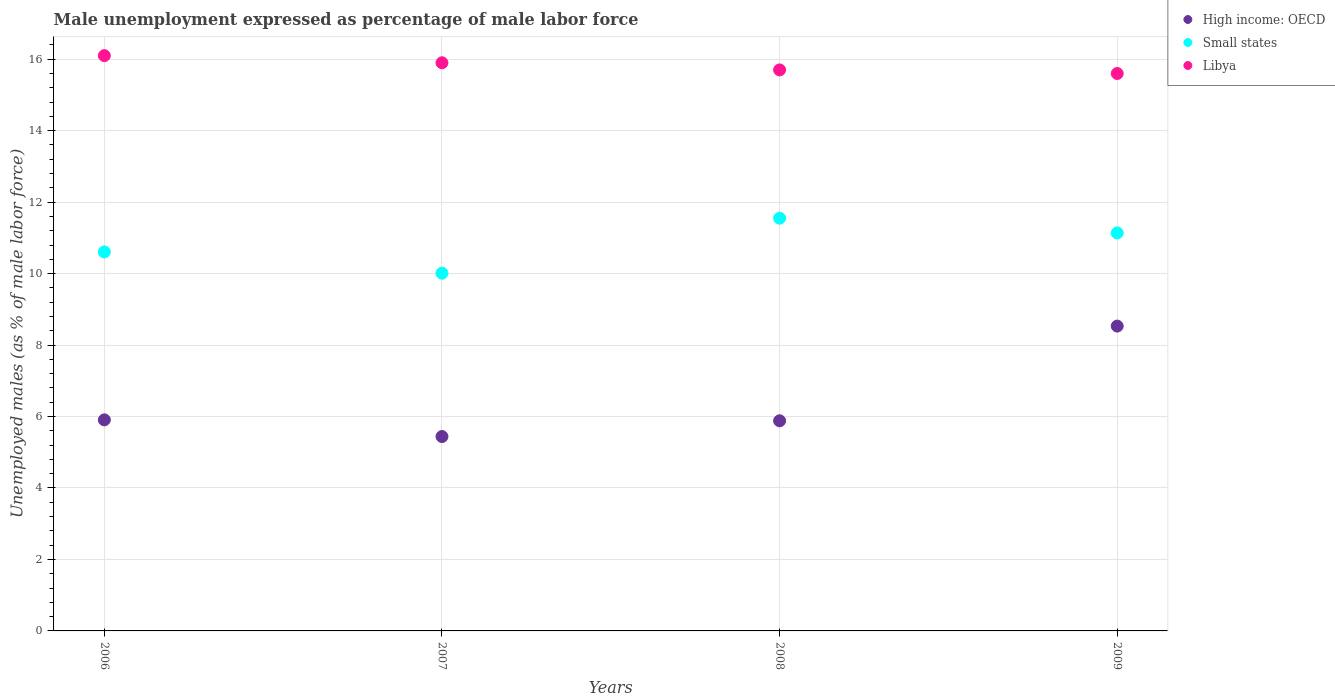How many different coloured dotlines are there?
Ensure brevity in your answer.  3. Is the number of dotlines equal to the number of legend labels?
Keep it short and to the point. Yes. What is the unemployment in males in in High income: OECD in 2007?
Offer a terse response. 5.44. Across all years, what is the maximum unemployment in males in in High income: OECD?
Offer a terse response. 8.53. Across all years, what is the minimum unemployment in males in in Small states?
Your response must be concise. 10.01. In which year was the unemployment in males in in Small states maximum?
Your answer should be compact. 2008. In which year was the unemployment in males in in High income: OECD minimum?
Keep it short and to the point. 2007. What is the total unemployment in males in in Small states in the graph?
Your answer should be very brief. 43.31. What is the difference between the unemployment in males in in Small states in 2007 and that in 2009?
Your response must be concise. -1.13. What is the difference between the unemployment in males in in Small states in 2007 and the unemployment in males in in Libya in 2008?
Offer a terse response. -5.69. What is the average unemployment in males in in High income: OECD per year?
Ensure brevity in your answer.  6.44. In the year 2007, what is the difference between the unemployment in males in in Small states and unemployment in males in in High income: OECD?
Ensure brevity in your answer.  4.57. What is the ratio of the unemployment in males in in Libya in 2006 to that in 2009?
Offer a terse response. 1.03. What is the difference between the highest and the second highest unemployment in males in in Small states?
Give a very brief answer. 0.41. What is the difference between the highest and the lowest unemployment in males in in Small states?
Offer a very short reply. 1.54. Is the sum of the unemployment in males in in Libya in 2007 and 2009 greater than the maximum unemployment in males in in High income: OECD across all years?
Provide a succinct answer. Yes. Is it the case that in every year, the sum of the unemployment in males in in Small states and unemployment in males in in Libya  is greater than the unemployment in males in in High income: OECD?
Keep it short and to the point. Yes. Are the values on the major ticks of Y-axis written in scientific E-notation?
Offer a terse response. No. Does the graph contain any zero values?
Give a very brief answer. No. Where does the legend appear in the graph?
Make the answer very short. Top right. How are the legend labels stacked?
Provide a short and direct response. Vertical. What is the title of the graph?
Your response must be concise. Male unemployment expressed as percentage of male labor force. Does "Marshall Islands" appear as one of the legend labels in the graph?
Give a very brief answer. No. What is the label or title of the Y-axis?
Make the answer very short. Unemployed males (as % of male labor force). What is the Unemployed males (as % of male labor force) of High income: OECD in 2006?
Offer a very short reply. 5.91. What is the Unemployed males (as % of male labor force) of Small states in 2006?
Your answer should be compact. 10.61. What is the Unemployed males (as % of male labor force) of Libya in 2006?
Your response must be concise. 16.1. What is the Unemployed males (as % of male labor force) in High income: OECD in 2007?
Your response must be concise. 5.44. What is the Unemployed males (as % of male labor force) of Small states in 2007?
Provide a succinct answer. 10.01. What is the Unemployed males (as % of male labor force) in Libya in 2007?
Make the answer very short. 15.9. What is the Unemployed males (as % of male labor force) in High income: OECD in 2008?
Provide a succinct answer. 5.88. What is the Unemployed males (as % of male labor force) in Small states in 2008?
Provide a short and direct response. 11.55. What is the Unemployed males (as % of male labor force) in Libya in 2008?
Provide a short and direct response. 15.7. What is the Unemployed males (as % of male labor force) of High income: OECD in 2009?
Ensure brevity in your answer.  8.53. What is the Unemployed males (as % of male labor force) in Small states in 2009?
Your answer should be compact. 11.14. What is the Unemployed males (as % of male labor force) in Libya in 2009?
Keep it short and to the point. 15.6. Across all years, what is the maximum Unemployed males (as % of male labor force) in High income: OECD?
Offer a very short reply. 8.53. Across all years, what is the maximum Unemployed males (as % of male labor force) of Small states?
Keep it short and to the point. 11.55. Across all years, what is the maximum Unemployed males (as % of male labor force) of Libya?
Your response must be concise. 16.1. Across all years, what is the minimum Unemployed males (as % of male labor force) in High income: OECD?
Your response must be concise. 5.44. Across all years, what is the minimum Unemployed males (as % of male labor force) in Small states?
Your response must be concise. 10.01. Across all years, what is the minimum Unemployed males (as % of male labor force) of Libya?
Make the answer very short. 15.6. What is the total Unemployed males (as % of male labor force) in High income: OECD in the graph?
Your answer should be very brief. 25.76. What is the total Unemployed males (as % of male labor force) of Small states in the graph?
Your response must be concise. 43.31. What is the total Unemployed males (as % of male labor force) in Libya in the graph?
Your response must be concise. 63.3. What is the difference between the Unemployed males (as % of male labor force) of High income: OECD in 2006 and that in 2007?
Give a very brief answer. 0.47. What is the difference between the Unemployed males (as % of male labor force) of Small states in 2006 and that in 2007?
Offer a terse response. 0.6. What is the difference between the Unemployed males (as % of male labor force) of High income: OECD in 2006 and that in 2008?
Make the answer very short. 0.03. What is the difference between the Unemployed males (as % of male labor force) in Small states in 2006 and that in 2008?
Provide a succinct answer. -0.94. What is the difference between the Unemployed males (as % of male labor force) of High income: OECD in 2006 and that in 2009?
Ensure brevity in your answer.  -2.62. What is the difference between the Unemployed males (as % of male labor force) of Small states in 2006 and that in 2009?
Provide a short and direct response. -0.53. What is the difference between the Unemployed males (as % of male labor force) of Libya in 2006 and that in 2009?
Your answer should be very brief. 0.5. What is the difference between the Unemployed males (as % of male labor force) of High income: OECD in 2007 and that in 2008?
Keep it short and to the point. -0.44. What is the difference between the Unemployed males (as % of male labor force) in Small states in 2007 and that in 2008?
Ensure brevity in your answer.  -1.54. What is the difference between the Unemployed males (as % of male labor force) in Libya in 2007 and that in 2008?
Offer a very short reply. 0.2. What is the difference between the Unemployed males (as % of male labor force) of High income: OECD in 2007 and that in 2009?
Provide a short and direct response. -3.09. What is the difference between the Unemployed males (as % of male labor force) in Small states in 2007 and that in 2009?
Provide a short and direct response. -1.13. What is the difference between the Unemployed males (as % of male labor force) of High income: OECD in 2008 and that in 2009?
Your answer should be compact. -2.65. What is the difference between the Unemployed males (as % of male labor force) of Small states in 2008 and that in 2009?
Offer a very short reply. 0.41. What is the difference between the Unemployed males (as % of male labor force) of High income: OECD in 2006 and the Unemployed males (as % of male labor force) of Small states in 2007?
Your response must be concise. -4.1. What is the difference between the Unemployed males (as % of male labor force) of High income: OECD in 2006 and the Unemployed males (as % of male labor force) of Libya in 2007?
Keep it short and to the point. -9.99. What is the difference between the Unemployed males (as % of male labor force) of Small states in 2006 and the Unemployed males (as % of male labor force) of Libya in 2007?
Your answer should be very brief. -5.29. What is the difference between the Unemployed males (as % of male labor force) of High income: OECD in 2006 and the Unemployed males (as % of male labor force) of Small states in 2008?
Your answer should be compact. -5.64. What is the difference between the Unemployed males (as % of male labor force) of High income: OECD in 2006 and the Unemployed males (as % of male labor force) of Libya in 2008?
Offer a very short reply. -9.79. What is the difference between the Unemployed males (as % of male labor force) in Small states in 2006 and the Unemployed males (as % of male labor force) in Libya in 2008?
Provide a succinct answer. -5.09. What is the difference between the Unemployed males (as % of male labor force) in High income: OECD in 2006 and the Unemployed males (as % of male labor force) in Small states in 2009?
Offer a terse response. -5.23. What is the difference between the Unemployed males (as % of male labor force) in High income: OECD in 2006 and the Unemployed males (as % of male labor force) in Libya in 2009?
Offer a terse response. -9.69. What is the difference between the Unemployed males (as % of male labor force) in Small states in 2006 and the Unemployed males (as % of male labor force) in Libya in 2009?
Give a very brief answer. -4.99. What is the difference between the Unemployed males (as % of male labor force) of High income: OECD in 2007 and the Unemployed males (as % of male labor force) of Small states in 2008?
Provide a succinct answer. -6.11. What is the difference between the Unemployed males (as % of male labor force) in High income: OECD in 2007 and the Unemployed males (as % of male labor force) in Libya in 2008?
Offer a terse response. -10.26. What is the difference between the Unemployed males (as % of male labor force) in Small states in 2007 and the Unemployed males (as % of male labor force) in Libya in 2008?
Give a very brief answer. -5.69. What is the difference between the Unemployed males (as % of male labor force) of High income: OECD in 2007 and the Unemployed males (as % of male labor force) of Small states in 2009?
Your answer should be compact. -5.7. What is the difference between the Unemployed males (as % of male labor force) in High income: OECD in 2007 and the Unemployed males (as % of male labor force) in Libya in 2009?
Keep it short and to the point. -10.16. What is the difference between the Unemployed males (as % of male labor force) of Small states in 2007 and the Unemployed males (as % of male labor force) of Libya in 2009?
Give a very brief answer. -5.59. What is the difference between the Unemployed males (as % of male labor force) in High income: OECD in 2008 and the Unemployed males (as % of male labor force) in Small states in 2009?
Provide a succinct answer. -5.26. What is the difference between the Unemployed males (as % of male labor force) of High income: OECD in 2008 and the Unemployed males (as % of male labor force) of Libya in 2009?
Provide a succinct answer. -9.72. What is the difference between the Unemployed males (as % of male labor force) of Small states in 2008 and the Unemployed males (as % of male labor force) of Libya in 2009?
Make the answer very short. -4.05. What is the average Unemployed males (as % of male labor force) of High income: OECD per year?
Offer a very short reply. 6.44. What is the average Unemployed males (as % of male labor force) of Small states per year?
Your response must be concise. 10.83. What is the average Unemployed males (as % of male labor force) in Libya per year?
Your answer should be very brief. 15.82. In the year 2006, what is the difference between the Unemployed males (as % of male labor force) of High income: OECD and Unemployed males (as % of male labor force) of Small states?
Your answer should be compact. -4.7. In the year 2006, what is the difference between the Unemployed males (as % of male labor force) of High income: OECD and Unemployed males (as % of male labor force) of Libya?
Make the answer very short. -10.19. In the year 2006, what is the difference between the Unemployed males (as % of male labor force) of Small states and Unemployed males (as % of male labor force) of Libya?
Ensure brevity in your answer.  -5.49. In the year 2007, what is the difference between the Unemployed males (as % of male labor force) of High income: OECD and Unemployed males (as % of male labor force) of Small states?
Your response must be concise. -4.57. In the year 2007, what is the difference between the Unemployed males (as % of male labor force) of High income: OECD and Unemployed males (as % of male labor force) of Libya?
Give a very brief answer. -10.46. In the year 2007, what is the difference between the Unemployed males (as % of male labor force) in Small states and Unemployed males (as % of male labor force) in Libya?
Make the answer very short. -5.89. In the year 2008, what is the difference between the Unemployed males (as % of male labor force) in High income: OECD and Unemployed males (as % of male labor force) in Small states?
Ensure brevity in your answer.  -5.67. In the year 2008, what is the difference between the Unemployed males (as % of male labor force) in High income: OECD and Unemployed males (as % of male labor force) in Libya?
Your answer should be very brief. -9.82. In the year 2008, what is the difference between the Unemployed males (as % of male labor force) of Small states and Unemployed males (as % of male labor force) of Libya?
Your response must be concise. -4.15. In the year 2009, what is the difference between the Unemployed males (as % of male labor force) in High income: OECD and Unemployed males (as % of male labor force) in Small states?
Your response must be concise. -2.61. In the year 2009, what is the difference between the Unemployed males (as % of male labor force) of High income: OECD and Unemployed males (as % of male labor force) of Libya?
Make the answer very short. -7.07. In the year 2009, what is the difference between the Unemployed males (as % of male labor force) in Small states and Unemployed males (as % of male labor force) in Libya?
Your answer should be compact. -4.46. What is the ratio of the Unemployed males (as % of male labor force) of High income: OECD in 2006 to that in 2007?
Provide a succinct answer. 1.09. What is the ratio of the Unemployed males (as % of male labor force) of Small states in 2006 to that in 2007?
Keep it short and to the point. 1.06. What is the ratio of the Unemployed males (as % of male labor force) in Libya in 2006 to that in 2007?
Offer a terse response. 1.01. What is the ratio of the Unemployed males (as % of male labor force) of Small states in 2006 to that in 2008?
Keep it short and to the point. 0.92. What is the ratio of the Unemployed males (as % of male labor force) of Libya in 2006 to that in 2008?
Keep it short and to the point. 1.03. What is the ratio of the Unemployed males (as % of male labor force) of High income: OECD in 2006 to that in 2009?
Make the answer very short. 0.69. What is the ratio of the Unemployed males (as % of male labor force) in Small states in 2006 to that in 2009?
Provide a succinct answer. 0.95. What is the ratio of the Unemployed males (as % of male labor force) in Libya in 2006 to that in 2009?
Give a very brief answer. 1.03. What is the ratio of the Unemployed males (as % of male labor force) of High income: OECD in 2007 to that in 2008?
Make the answer very short. 0.93. What is the ratio of the Unemployed males (as % of male labor force) of Small states in 2007 to that in 2008?
Provide a short and direct response. 0.87. What is the ratio of the Unemployed males (as % of male labor force) in Libya in 2007 to that in 2008?
Keep it short and to the point. 1.01. What is the ratio of the Unemployed males (as % of male labor force) in High income: OECD in 2007 to that in 2009?
Your response must be concise. 0.64. What is the ratio of the Unemployed males (as % of male labor force) of Small states in 2007 to that in 2009?
Ensure brevity in your answer.  0.9. What is the ratio of the Unemployed males (as % of male labor force) in Libya in 2007 to that in 2009?
Your answer should be very brief. 1.02. What is the ratio of the Unemployed males (as % of male labor force) of High income: OECD in 2008 to that in 2009?
Provide a short and direct response. 0.69. What is the ratio of the Unemployed males (as % of male labor force) in Small states in 2008 to that in 2009?
Your answer should be compact. 1.04. What is the ratio of the Unemployed males (as % of male labor force) of Libya in 2008 to that in 2009?
Offer a very short reply. 1.01. What is the difference between the highest and the second highest Unemployed males (as % of male labor force) of High income: OECD?
Provide a succinct answer. 2.62. What is the difference between the highest and the second highest Unemployed males (as % of male labor force) in Small states?
Ensure brevity in your answer.  0.41. What is the difference between the highest and the second highest Unemployed males (as % of male labor force) of Libya?
Your response must be concise. 0.2. What is the difference between the highest and the lowest Unemployed males (as % of male labor force) of High income: OECD?
Your response must be concise. 3.09. What is the difference between the highest and the lowest Unemployed males (as % of male labor force) in Small states?
Your response must be concise. 1.54. What is the difference between the highest and the lowest Unemployed males (as % of male labor force) of Libya?
Keep it short and to the point. 0.5. 